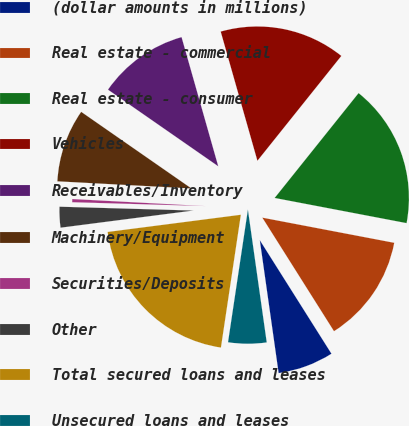<chart> <loc_0><loc_0><loc_500><loc_500><pie_chart><fcel>(dollar amounts in millions)<fcel>Real estate - commercial<fcel>Real estate - consumer<fcel>Vehicles<fcel>Receivables/Inventory<fcel>Machinery/Equipment<fcel>Securities/Deposits<fcel>Other<fcel>Total secured loans and leases<fcel>Unsecured loans and leases<nl><fcel>6.72%<fcel>13.04%<fcel>17.26%<fcel>15.15%<fcel>10.93%<fcel>8.82%<fcel>0.39%<fcel>2.5%<fcel>20.59%<fcel>4.61%<nl></chart> 